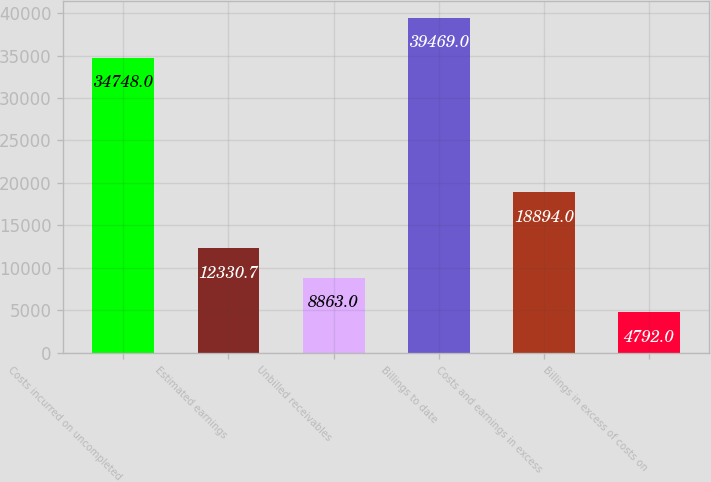Convert chart. <chart><loc_0><loc_0><loc_500><loc_500><bar_chart><fcel>Costs incurred on uncompleted<fcel>Estimated earnings<fcel>Unbilled receivables<fcel>Billings to date<fcel>Costs and earnings in excess<fcel>Billings in excess of costs on<nl><fcel>34748<fcel>12330.7<fcel>8863<fcel>39469<fcel>18894<fcel>4792<nl></chart> 